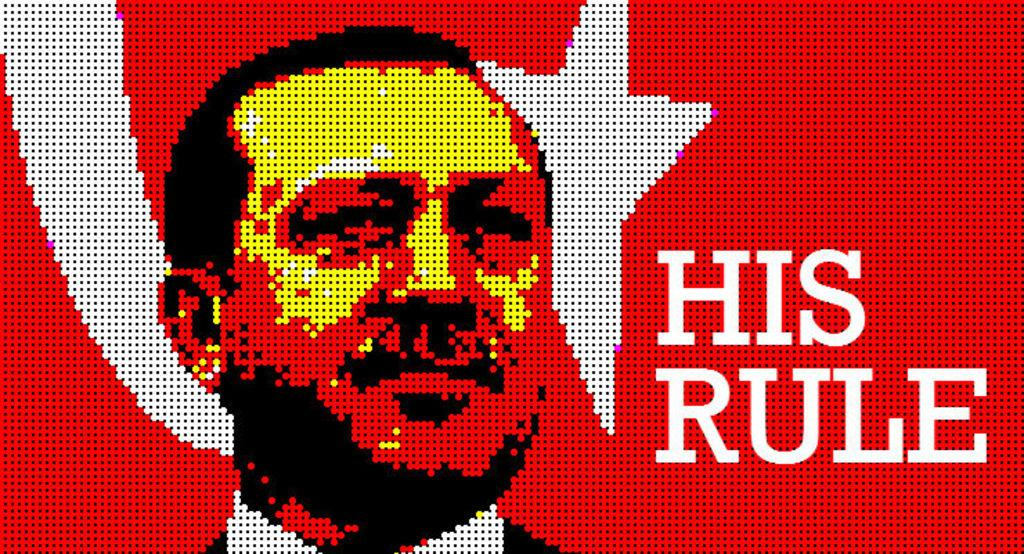<image>
Offer a succinct explanation of the picture presented. A photo features a man and says his rule next to his face. 